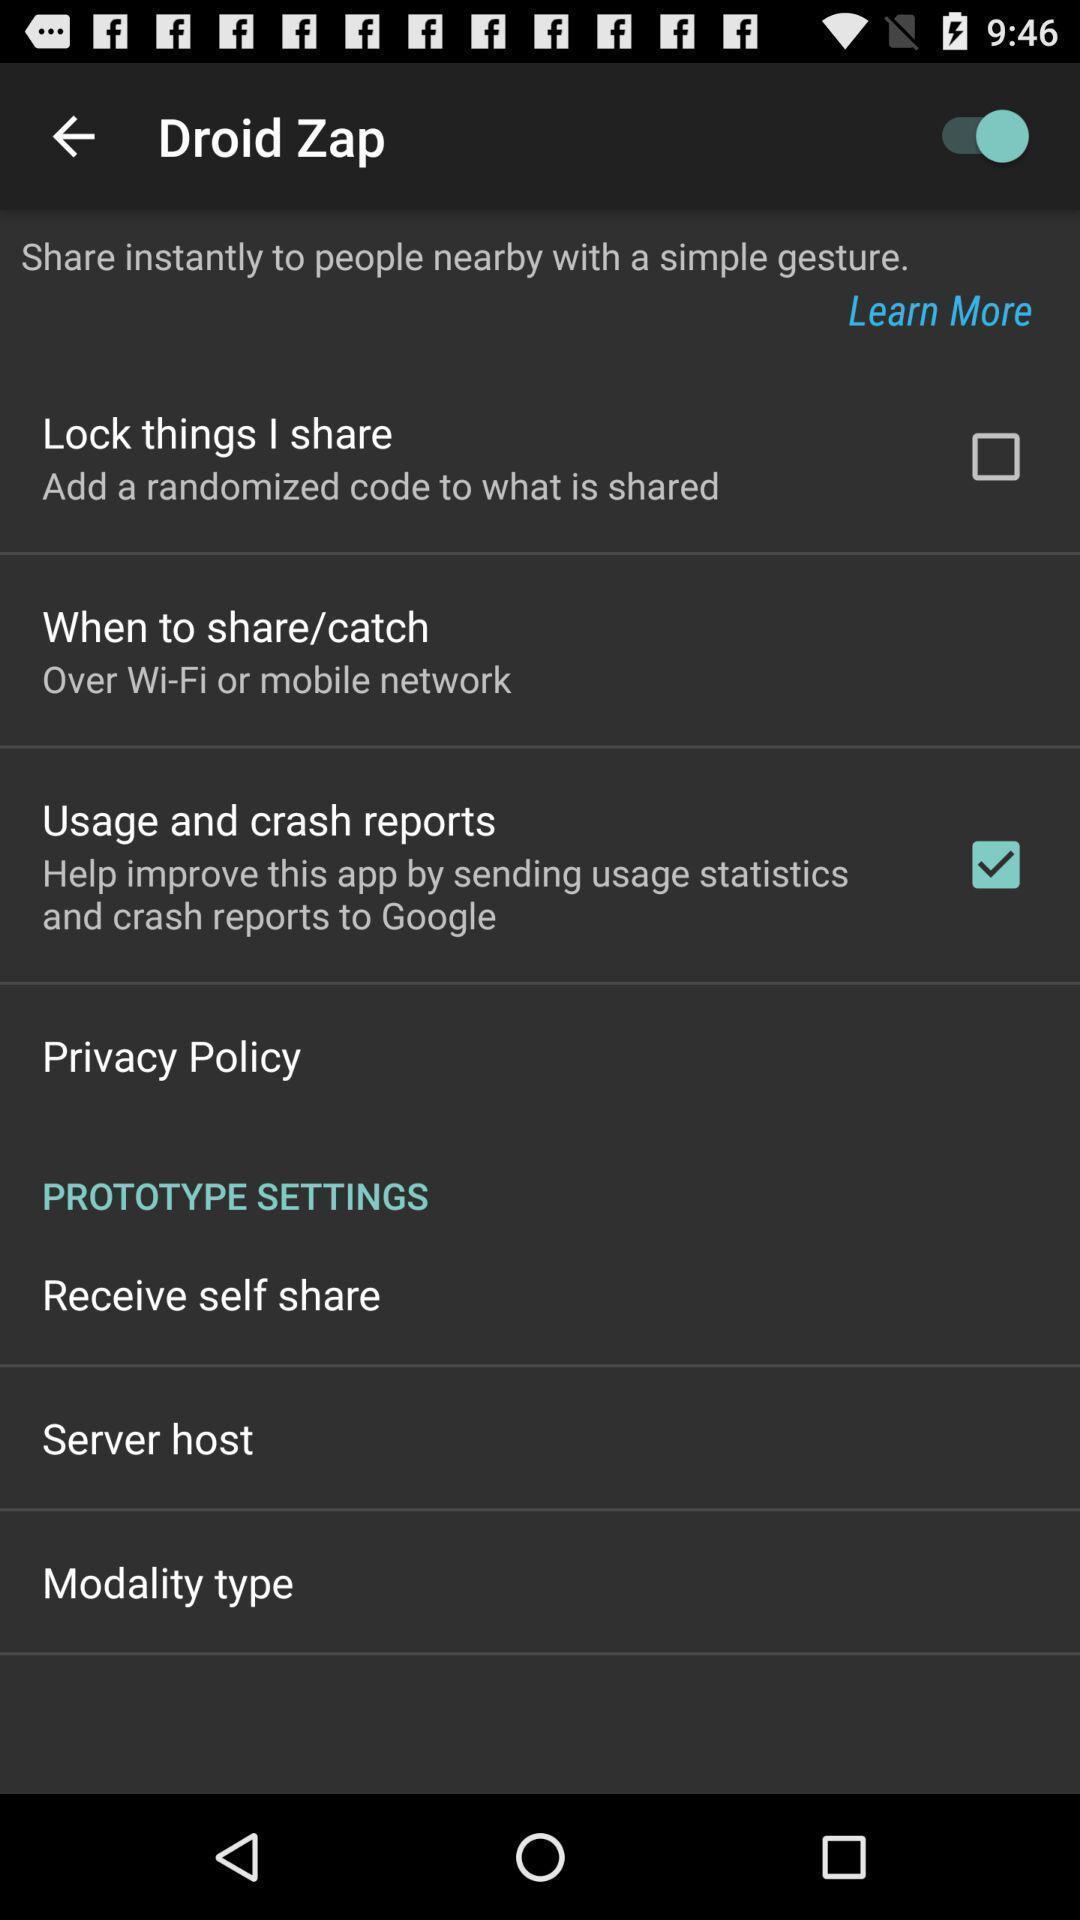Describe the key features of this screenshot. Screen shows general setting. 